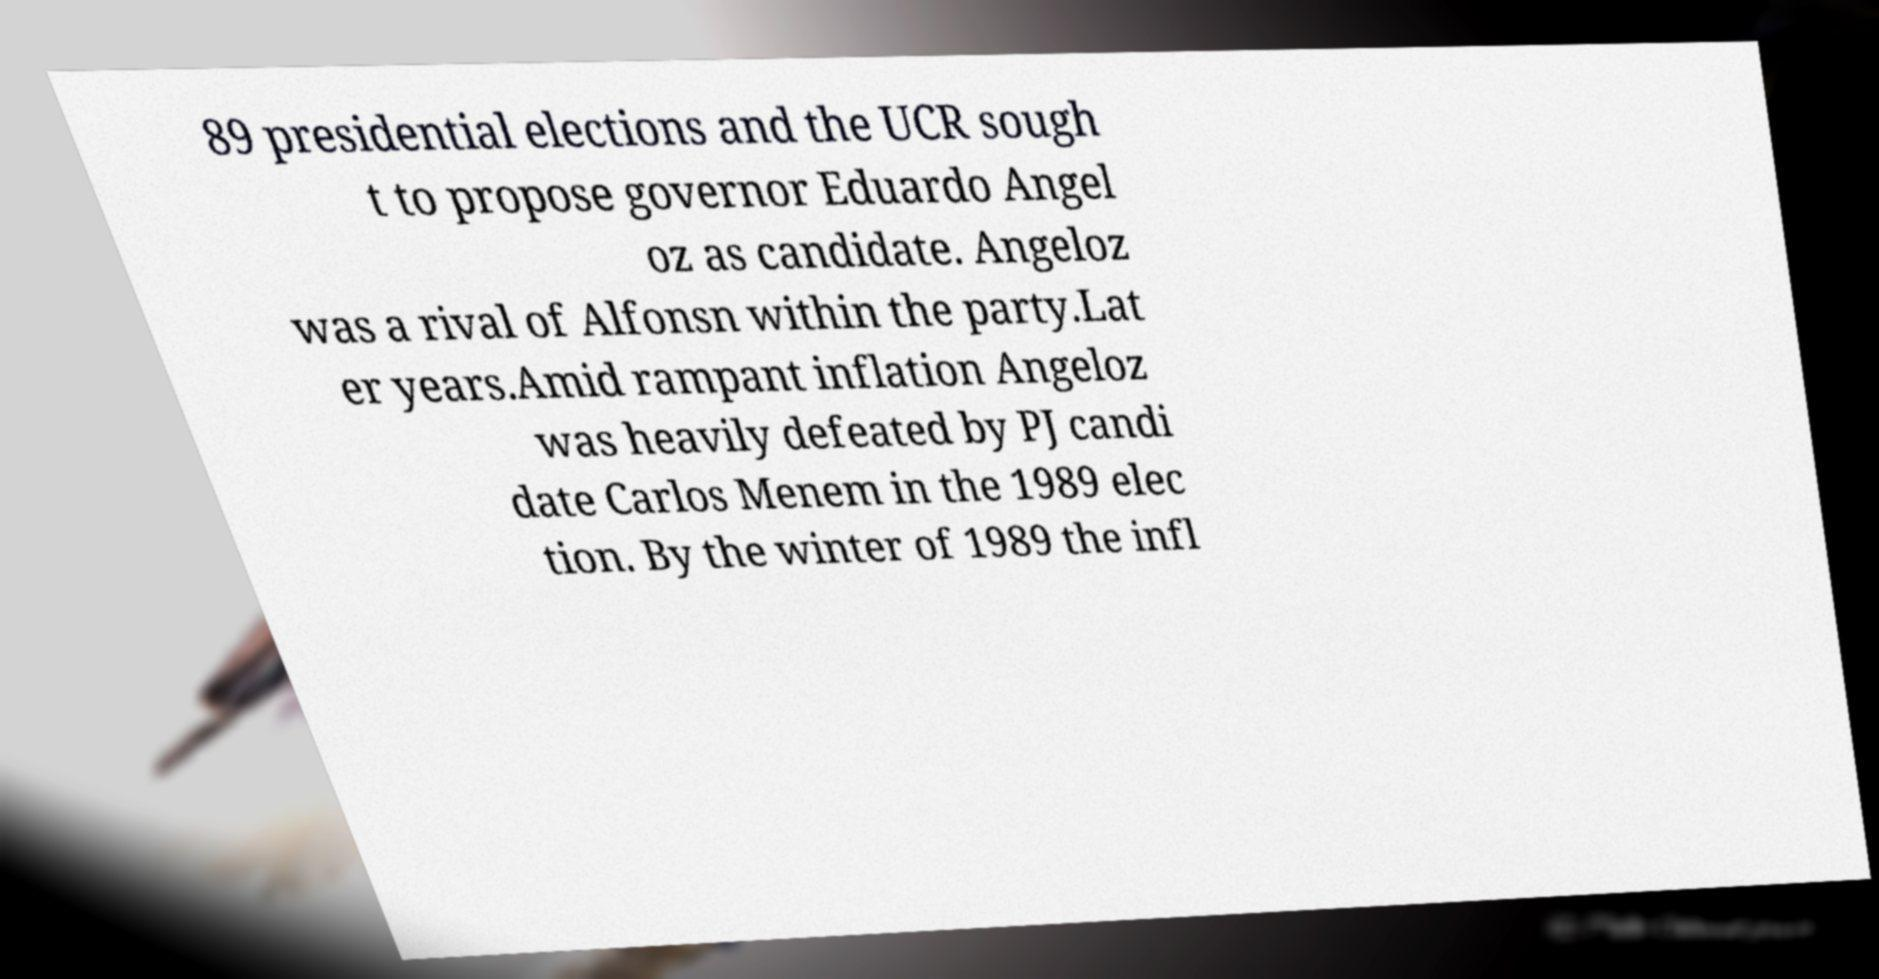Can you read and provide the text displayed in the image?This photo seems to have some interesting text. Can you extract and type it out for me? 89 presidential elections and the UCR sough t to propose governor Eduardo Angel oz as candidate. Angeloz was a rival of Alfonsn within the party.Lat er years.Amid rampant inflation Angeloz was heavily defeated by PJ candi date Carlos Menem in the 1989 elec tion. By the winter of 1989 the infl 